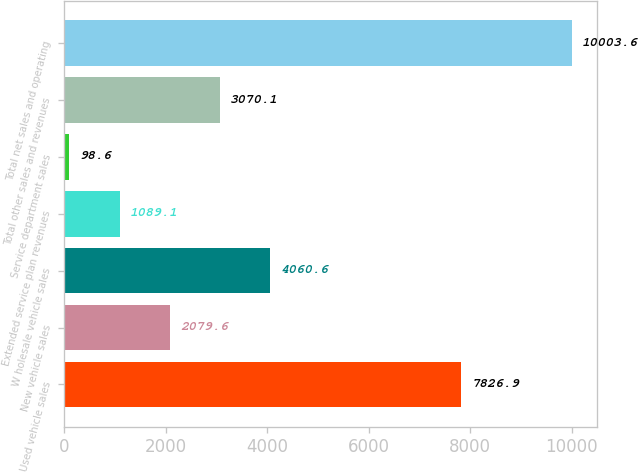Convert chart. <chart><loc_0><loc_0><loc_500><loc_500><bar_chart><fcel>Used vehicle sales<fcel>New vehicle sales<fcel>W holesale vehicle sales<fcel>Extended service plan revenues<fcel>Service department sales<fcel>Total other sales and revenues<fcel>Total net sales and operating<nl><fcel>7826.9<fcel>2079.6<fcel>4060.6<fcel>1089.1<fcel>98.6<fcel>3070.1<fcel>10003.6<nl></chart> 